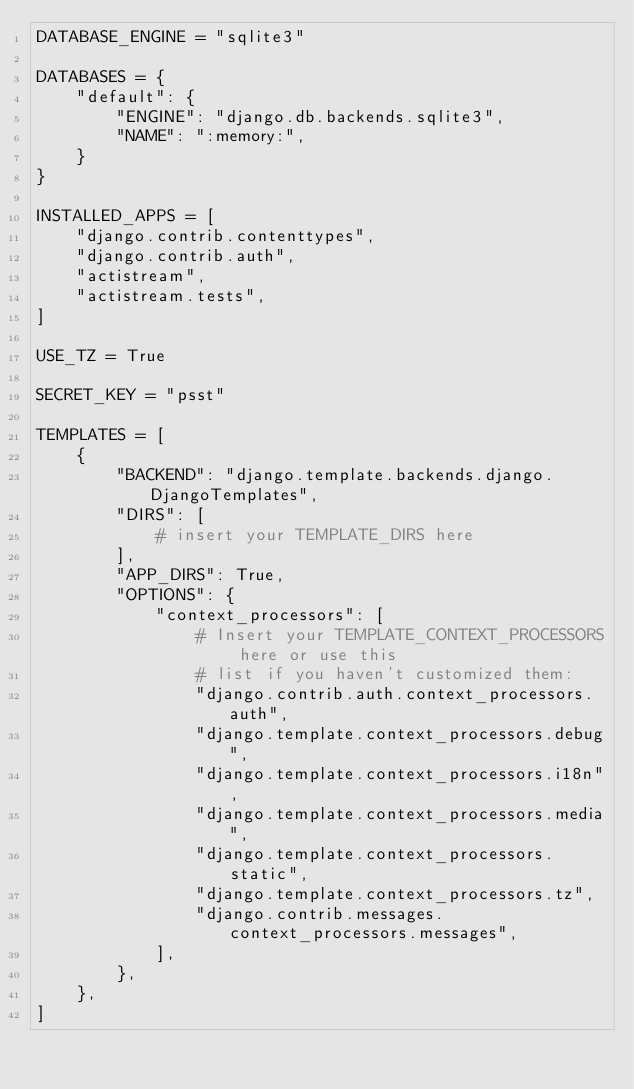<code> <loc_0><loc_0><loc_500><loc_500><_Python_>DATABASE_ENGINE = "sqlite3"

DATABASES = {
    "default": {
        "ENGINE": "django.db.backends.sqlite3",
        "NAME": ":memory:",
    }
}

INSTALLED_APPS = [
    "django.contrib.contenttypes",
    "django.contrib.auth",
    "actistream",
    "actistream.tests",
]

USE_TZ = True

SECRET_KEY = "psst"

TEMPLATES = [
    {
        "BACKEND": "django.template.backends.django.DjangoTemplates",
        "DIRS": [
            # insert your TEMPLATE_DIRS here
        ],
        "APP_DIRS": True,
        "OPTIONS": {
            "context_processors": [
                # Insert your TEMPLATE_CONTEXT_PROCESSORS here or use this
                # list if you haven't customized them:
                "django.contrib.auth.context_processors.auth",
                "django.template.context_processors.debug",
                "django.template.context_processors.i18n",
                "django.template.context_processors.media",
                "django.template.context_processors.static",
                "django.template.context_processors.tz",
                "django.contrib.messages.context_processors.messages",
            ],
        },
    },
]
</code> 